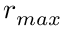Convert formula to latex. <formula><loc_0><loc_0><loc_500><loc_500>r _ { \max }</formula> 